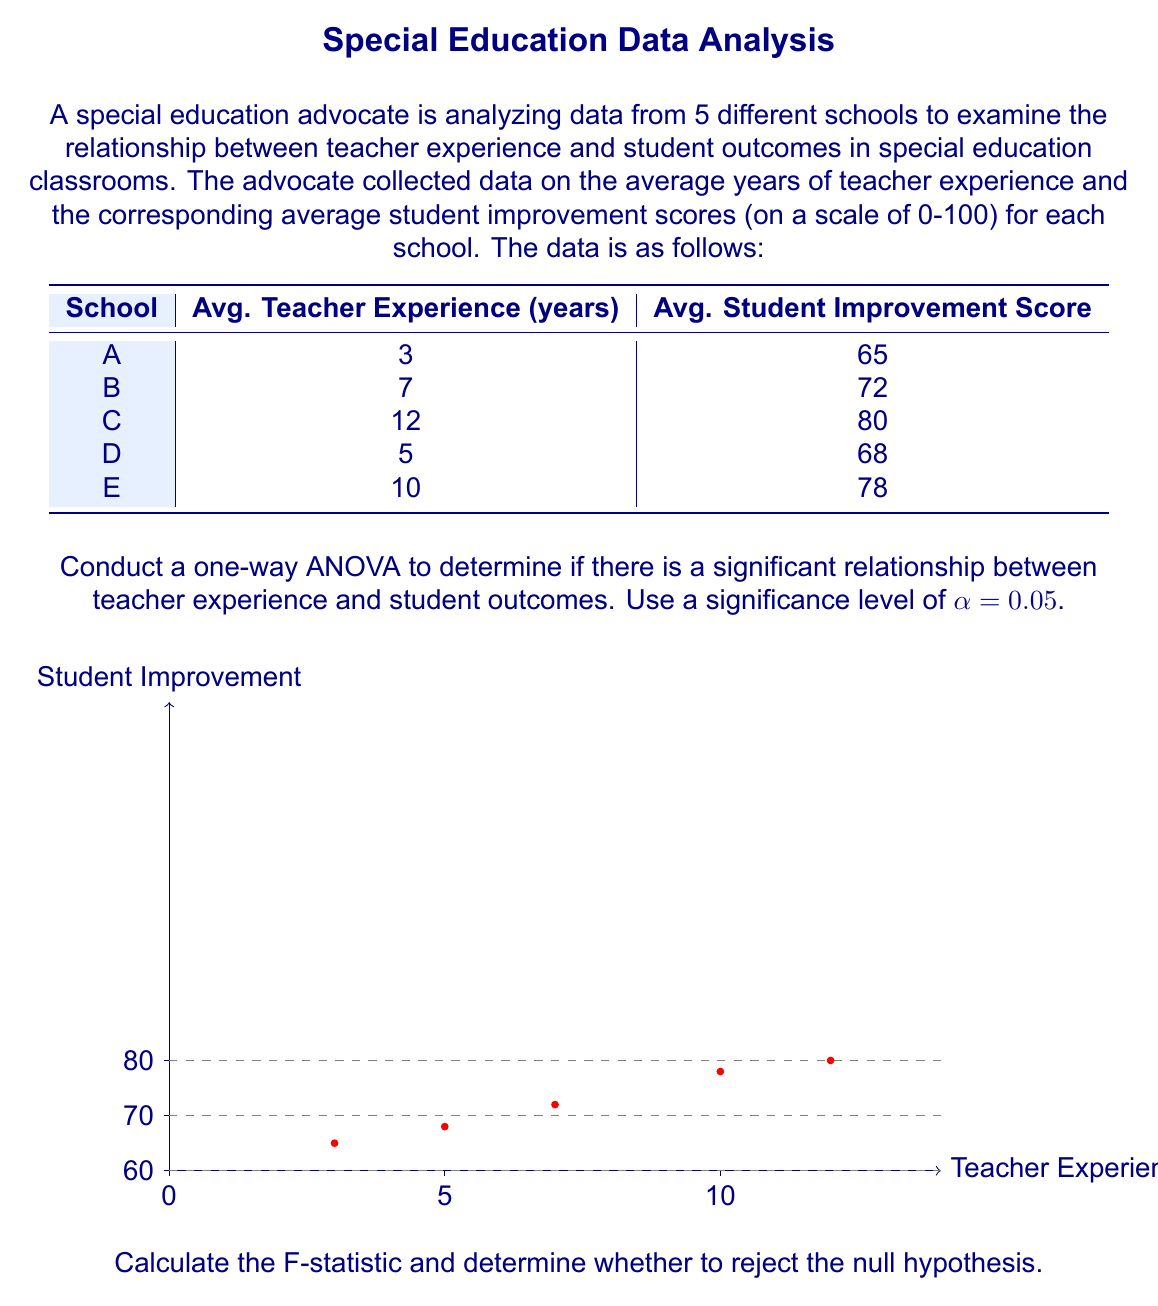Help me with this question. To conduct a one-way ANOVA, we'll follow these steps:

1) Calculate the total sum of squares (SST):
   $$SST = \sum_{i=1}^{n} (y_i - \bar{y})^2$$
   where $y_i$ are the individual student improvement scores and $\bar{y}$ is the mean of all scores.

2) Calculate the regression sum of squares (SSR):
   $$SSR = \sum_{i=1}^{k} n_i(\bar{y}_i - \bar{y})^2$$
   where $k$ is the number of groups (schools), $n_i$ is the number of observations in each group (1 in this case), and $\bar{y}_i$ is the mean of each group.

3) Calculate the error sum of squares (SSE):
   $$SSE = SST - SSR$$

4) Calculate the degrees of freedom:
   $df_{between} = k - 1 = 5 - 1 = 4$
   $df_{within} = n - k = 5 - 5 = 0$
   $df_{total} = n - 1 = 5 - 1 = 4$

5) Calculate the mean square between (MSB) and mean square within (MSW):
   $$MSB = \frac{SSR}{df_{between}}$$
   $$MSW = \frac{SSE}{df_{within}}$$

6) Calculate the F-statistic:
   $$F = \frac{MSB}{MSW}$$

7) Compare the F-statistic to the critical F-value at α = 0.05.

Calculations:

$\bar{y} = \frac{65 + 72 + 80 + 68 + 78}{5} = 72.6$

$SST = (65-72.6)^2 + (72-72.6)^2 + (80-72.6)^2 + (68-72.6)^2 + (78-72.6)^2 = 190.8$

$SSR = 1(65-72.6)^2 + 1(72-72.6)^2 + 1(80-72.6)^2 + 1(68-72.6)^2 + 1(78-72.6)^2 = 190.8$

$SSE = SST - SSR = 190.8 - 190.8 = 0$

$MSB = \frac{190.8}{4} = 47.7$

$MSW = \frac{0}{0}$ (undefined)

The F-statistic cannot be calculated because MSW is undefined (division by zero).

In this case, because we have only one observation per group, the within-group variance is zero, leading to an undefined F-statistic. This highlights a limitation of using ANOVA with this particular dataset.

Given this limitation, we cannot perform the ANOVA as intended. Instead, we might consider using a simple linear regression to examine the relationship between teacher experience and student outcomes.
Answer: ANOVA cannot be performed due to zero within-group variance. Consider linear regression instead. 